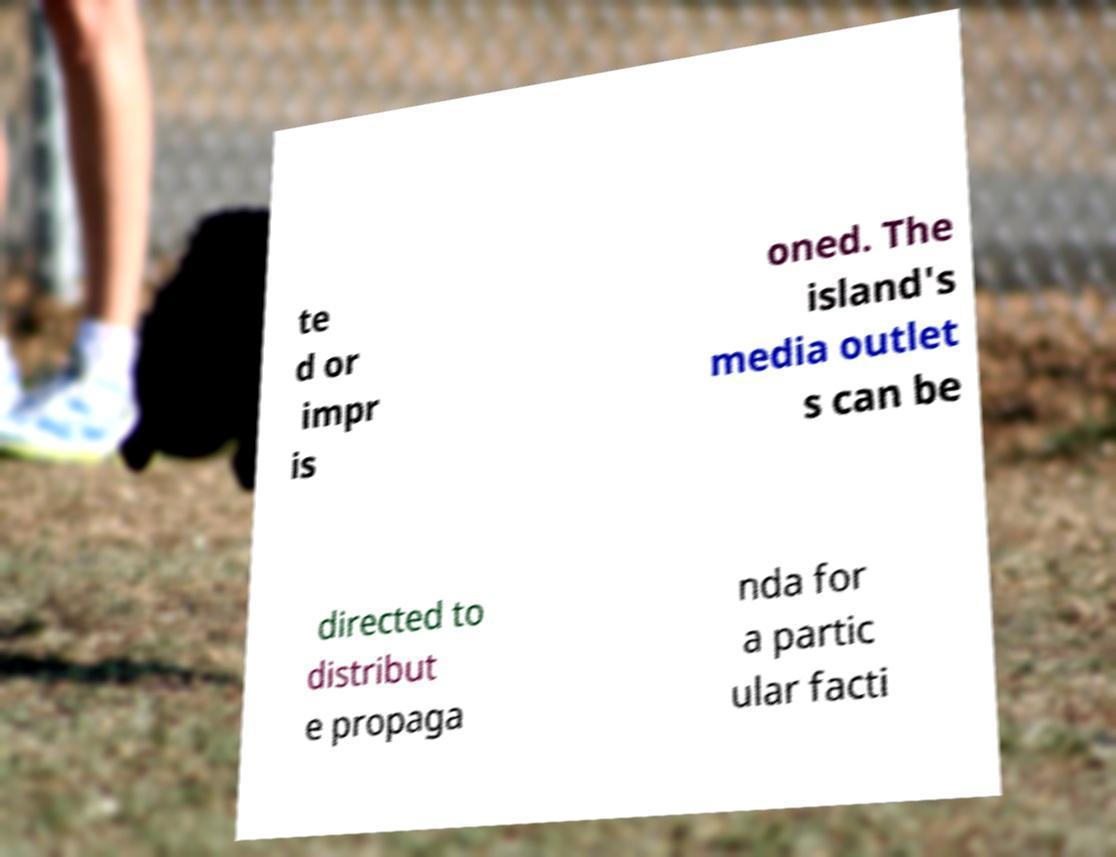Could you extract and type out the text from this image? te d or impr is oned. The island's media outlet s can be directed to distribut e propaga nda for a partic ular facti 